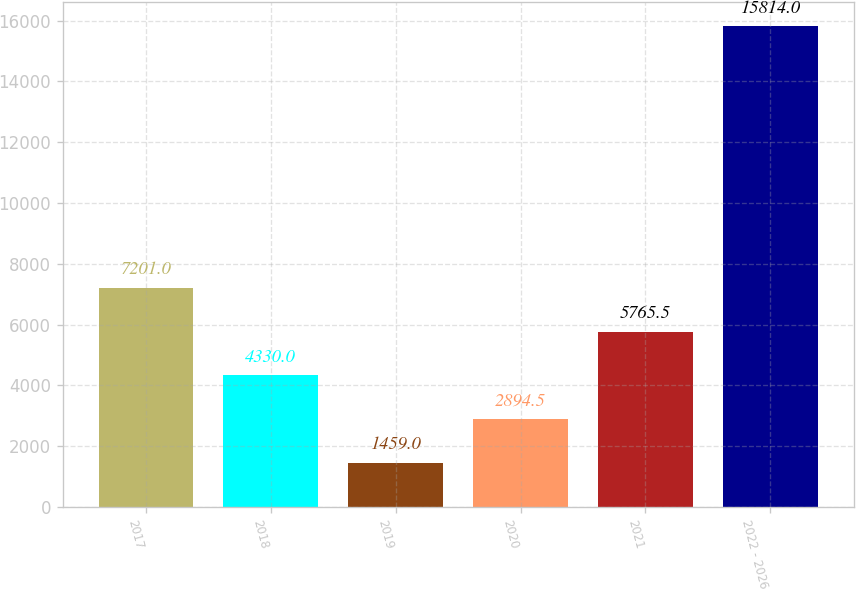<chart> <loc_0><loc_0><loc_500><loc_500><bar_chart><fcel>2017<fcel>2018<fcel>2019<fcel>2020<fcel>2021<fcel>2022 - 2026<nl><fcel>7201<fcel>4330<fcel>1459<fcel>2894.5<fcel>5765.5<fcel>15814<nl></chart> 